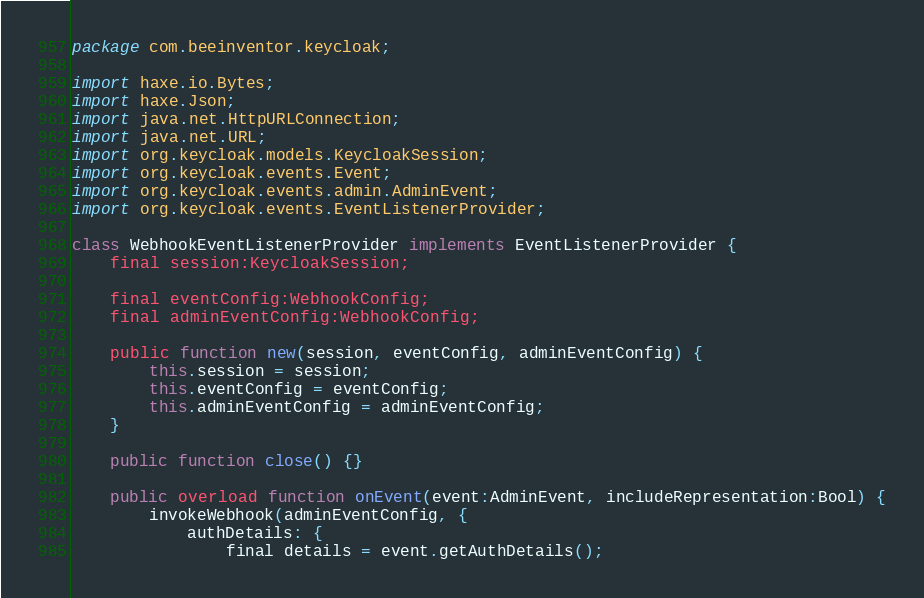<code> <loc_0><loc_0><loc_500><loc_500><_Haxe_>package com.beeinventor.keycloak;

import haxe.io.Bytes;
import haxe.Json;
import java.net.HttpURLConnection;
import java.net.URL;
import org.keycloak.models.KeycloakSession;
import org.keycloak.events.Event;
import org.keycloak.events.admin.AdminEvent;
import org.keycloak.events.EventListenerProvider;

class WebhookEventListenerProvider implements EventListenerProvider {
	final session:KeycloakSession;
	
	final eventConfig:WebhookConfig;
	final adminEventConfig:WebhookConfig;
	
	public function new(session, eventConfig, adminEventConfig) {
		this.session = session;
		this.eventConfig = eventConfig;
		this.adminEventConfig = adminEventConfig;
	}
	
	public function close() {}

	public overload function onEvent(event:AdminEvent, includeRepresentation:Bool) {
		invokeWebhook(adminEventConfig, {
			authDetails: {
				final details = event.getAuthDetails();</code> 